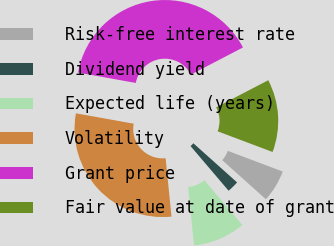Convert chart to OTSL. <chart><loc_0><loc_0><loc_500><loc_500><pie_chart><fcel>Risk-free interest rate<fcel>Dividend yield<fcel>Expected life (years)<fcel>Volatility<fcel>Grant price<fcel>Fair value at date of grant<nl><fcel>5.89%<fcel>2.15%<fcel>9.63%<fcel>29.43%<fcel>39.53%<fcel>13.37%<nl></chart> 